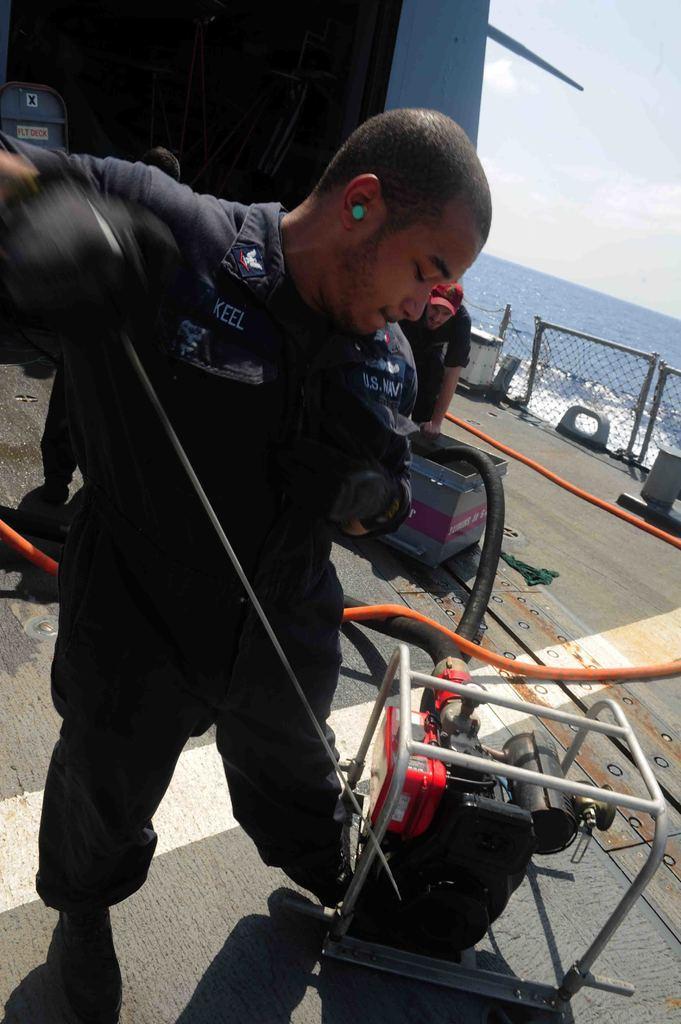Could you give a brief overview of what you see in this image? In this image I can see few people are standing and I can see the machine, pipe and few objects around. In the background I can see the water and the fencing. 